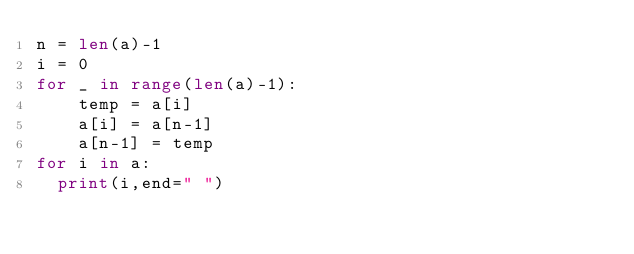Convert code to text. <code><loc_0><loc_0><loc_500><loc_500><_Python_>n = len(a)-1
i = 0
for _ in range(len(a)-1):
    temp = a[i]
    a[i] = a[n-1]
    a[n-1] = temp
for i in a:
  print(i,end=" ")</code> 